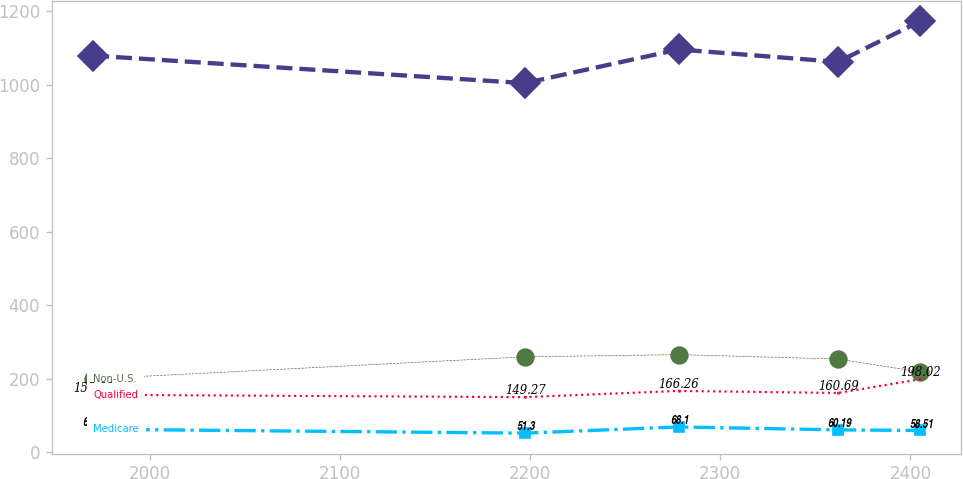Convert chart. <chart><loc_0><loc_0><loc_500><loc_500><line_chart><ecel><fcel>Unnamed: 1<fcel>Medicare<fcel>Non-U.S.<fcel>Qualified<nl><fcel>1970.21<fcel>1079.44<fcel>61.87<fcel>199.13<fcel>155.82<nl><fcel>2197.14<fcel>1004.51<fcel>51.3<fcel>259.13<fcel>149.27<nl><fcel>2278.08<fcel>1096.27<fcel>68.1<fcel>265.08<fcel>166.26<nl><fcel>2361.89<fcel>1062.35<fcel>60.19<fcel>253.18<fcel>160.69<nl><fcel>2405<fcel>1172.83<fcel>58.51<fcel>217.97<fcel>198.02<nl></chart> 